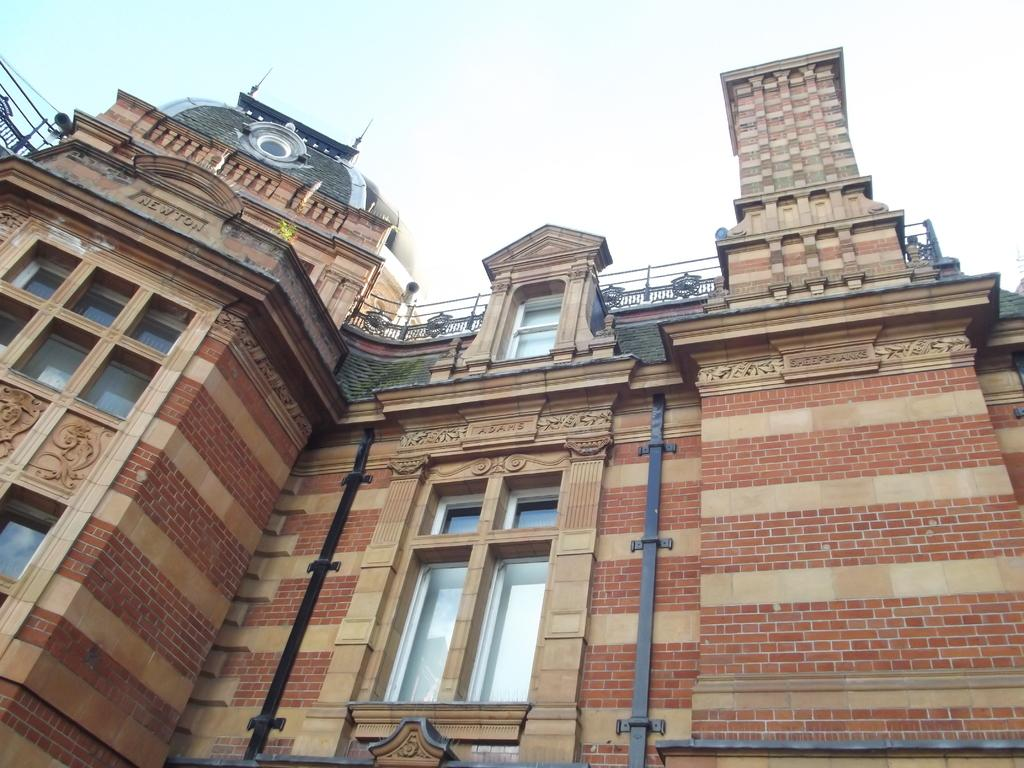What type of structure is present in the image? There is a building in the image. What can be seen above the building in the image? The sky is visible at the top of the image. How many women are knitting with yarn in the image? There are no women or yarn present in the image; it only features a building and the sky. 